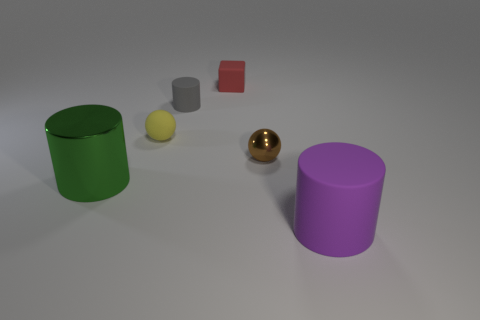Subtract all green shiny cylinders. How many cylinders are left? 2 Add 2 cylinders. How many objects exist? 8 Subtract all cubes. How many objects are left? 5 Add 4 green shiny things. How many green shiny things exist? 5 Subtract all purple cylinders. How many cylinders are left? 2 Subtract 0 green blocks. How many objects are left? 6 Subtract 1 cylinders. How many cylinders are left? 2 Subtract all brown balls. Subtract all gray cubes. How many balls are left? 1 Subtract all gray cylinders. How many brown balls are left? 1 Subtract all yellow balls. Subtract all small brown metal cubes. How many objects are left? 5 